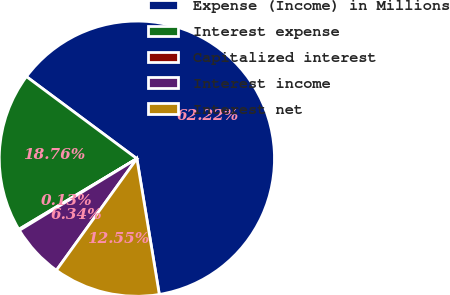Convert chart to OTSL. <chart><loc_0><loc_0><loc_500><loc_500><pie_chart><fcel>Expense (Income) in Millions<fcel>Interest expense<fcel>Capitalized interest<fcel>Interest income<fcel>Interest net<nl><fcel>62.23%<fcel>18.76%<fcel>0.13%<fcel>6.34%<fcel>12.55%<nl></chart> 